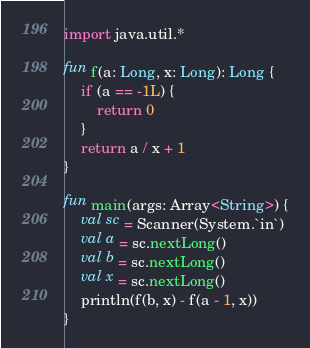Convert code to text. <code><loc_0><loc_0><loc_500><loc_500><_Kotlin_>import java.util.*

fun f(a: Long, x: Long): Long {
    if (a == -1L) {
        return 0
    }
    return a / x + 1
}

fun main(args: Array<String>) {
    val sc = Scanner(System.`in`)
    val a = sc.nextLong()
    val b = sc.nextLong()
    val x = sc.nextLong()
    println(f(b, x) - f(a - 1, x))
}</code> 